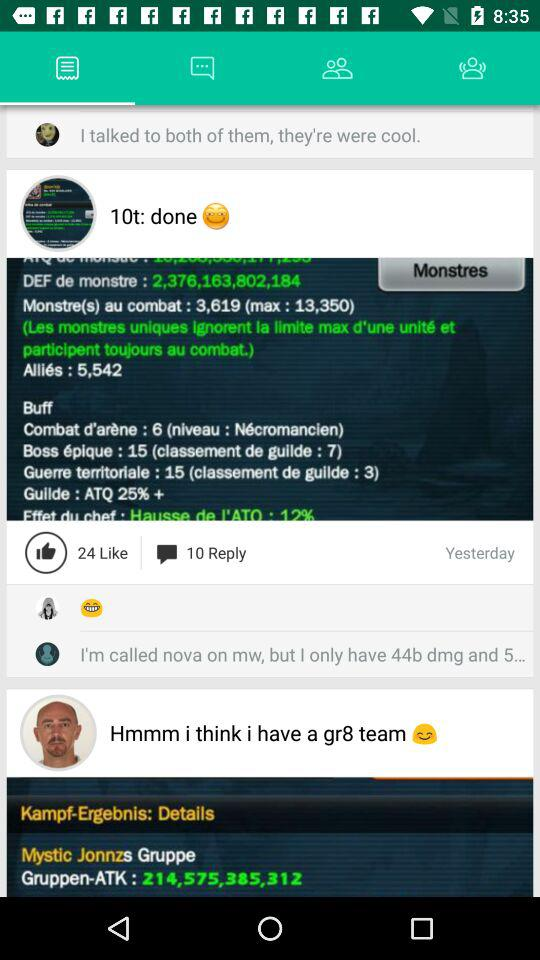How many replies are there? There are 10 replies. 